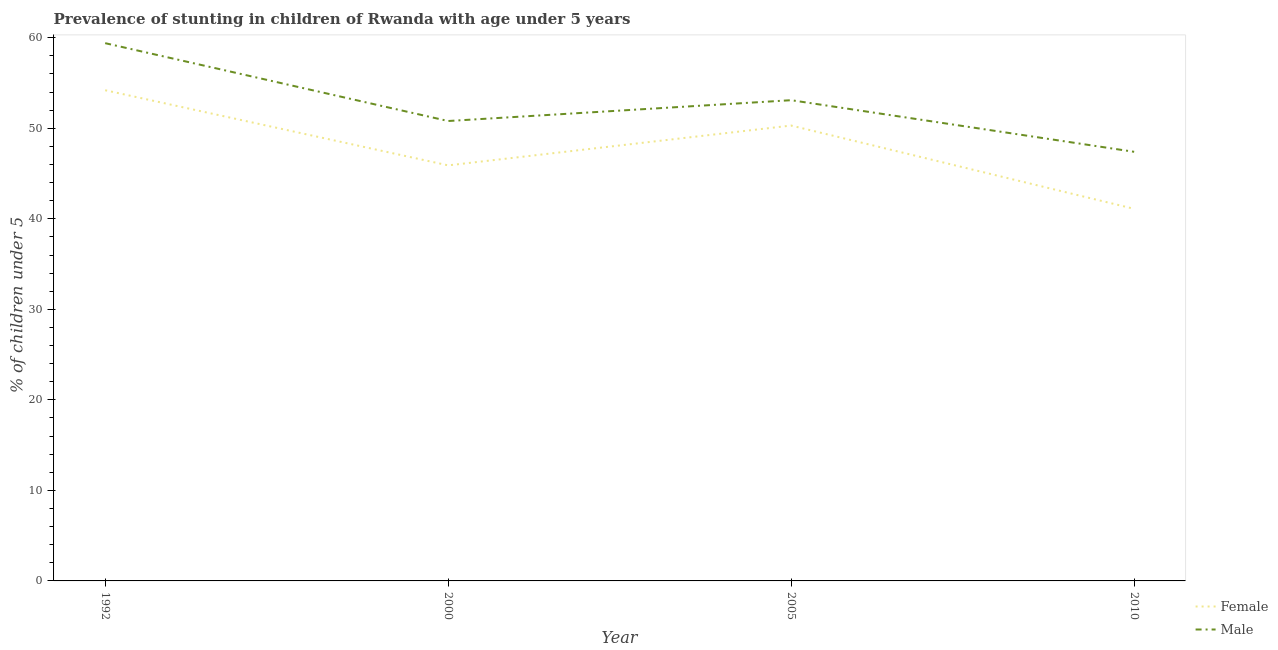How many different coloured lines are there?
Provide a succinct answer. 2. Is the number of lines equal to the number of legend labels?
Your answer should be very brief. Yes. What is the percentage of stunted male children in 1992?
Keep it short and to the point. 59.4. Across all years, what is the maximum percentage of stunted female children?
Keep it short and to the point. 54.2. Across all years, what is the minimum percentage of stunted female children?
Offer a terse response. 41.1. In which year was the percentage of stunted male children maximum?
Provide a succinct answer. 1992. What is the total percentage of stunted male children in the graph?
Your answer should be compact. 210.7. What is the difference between the percentage of stunted male children in 2000 and that in 2010?
Your answer should be very brief. 3.4. What is the average percentage of stunted male children per year?
Your answer should be very brief. 52.68. In the year 2010, what is the difference between the percentage of stunted male children and percentage of stunted female children?
Ensure brevity in your answer.  6.3. In how many years, is the percentage of stunted female children greater than 42 %?
Give a very brief answer. 3. What is the ratio of the percentage of stunted female children in 2000 to that in 2005?
Give a very brief answer. 0.91. Is the difference between the percentage of stunted female children in 2000 and 2005 greater than the difference between the percentage of stunted male children in 2000 and 2005?
Make the answer very short. No. What is the difference between the highest and the second highest percentage of stunted male children?
Offer a very short reply. 6.3. Is the sum of the percentage of stunted male children in 2005 and 2010 greater than the maximum percentage of stunted female children across all years?
Provide a short and direct response. Yes. Is the percentage of stunted male children strictly less than the percentage of stunted female children over the years?
Keep it short and to the point. No. How many lines are there?
Provide a succinct answer. 2. Does the graph contain any zero values?
Give a very brief answer. No. Does the graph contain grids?
Provide a short and direct response. No. Where does the legend appear in the graph?
Your answer should be very brief. Bottom right. What is the title of the graph?
Your answer should be compact. Prevalence of stunting in children of Rwanda with age under 5 years. Does "DAC donors" appear as one of the legend labels in the graph?
Ensure brevity in your answer.  No. What is the label or title of the Y-axis?
Make the answer very short.  % of children under 5. What is the  % of children under 5 of Female in 1992?
Make the answer very short. 54.2. What is the  % of children under 5 of Male in 1992?
Ensure brevity in your answer.  59.4. What is the  % of children under 5 of Female in 2000?
Offer a terse response. 45.9. What is the  % of children under 5 of Male in 2000?
Keep it short and to the point. 50.8. What is the  % of children under 5 in Female in 2005?
Your answer should be very brief. 50.3. What is the  % of children under 5 in Male in 2005?
Ensure brevity in your answer.  53.1. What is the  % of children under 5 of Female in 2010?
Provide a short and direct response. 41.1. What is the  % of children under 5 of Male in 2010?
Provide a succinct answer. 47.4. Across all years, what is the maximum  % of children under 5 of Female?
Keep it short and to the point. 54.2. Across all years, what is the maximum  % of children under 5 of Male?
Keep it short and to the point. 59.4. Across all years, what is the minimum  % of children under 5 of Female?
Offer a terse response. 41.1. Across all years, what is the minimum  % of children under 5 of Male?
Provide a short and direct response. 47.4. What is the total  % of children under 5 in Female in the graph?
Ensure brevity in your answer.  191.5. What is the total  % of children under 5 in Male in the graph?
Provide a succinct answer. 210.7. What is the difference between the  % of children under 5 in Female in 1992 and that in 2000?
Offer a terse response. 8.3. What is the difference between the  % of children under 5 in Male in 1992 and that in 2005?
Ensure brevity in your answer.  6.3. What is the difference between the  % of children under 5 of Female in 1992 and that in 2010?
Ensure brevity in your answer.  13.1. What is the difference between the  % of children under 5 in Female in 2000 and that in 2005?
Provide a succinct answer. -4.4. What is the difference between the  % of children under 5 of Female in 2000 and that in 2010?
Make the answer very short. 4.8. What is the difference between the  % of children under 5 of Female in 2005 and that in 2010?
Your answer should be compact. 9.2. What is the difference between the  % of children under 5 of Female in 1992 and the  % of children under 5 of Male in 2000?
Offer a terse response. 3.4. What is the difference between the  % of children under 5 of Female in 2005 and the  % of children under 5 of Male in 2010?
Keep it short and to the point. 2.9. What is the average  % of children under 5 of Female per year?
Provide a succinct answer. 47.88. What is the average  % of children under 5 of Male per year?
Your response must be concise. 52.67. In the year 2000, what is the difference between the  % of children under 5 of Female and  % of children under 5 of Male?
Provide a succinct answer. -4.9. In the year 2005, what is the difference between the  % of children under 5 in Female and  % of children under 5 in Male?
Offer a very short reply. -2.8. What is the ratio of the  % of children under 5 of Female in 1992 to that in 2000?
Your answer should be compact. 1.18. What is the ratio of the  % of children under 5 of Male in 1992 to that in 2000?
Offer a terse response. 1.17. What is the ratio of the  % of children under 5 in Female in 1992 to that in 2005?
Offer a very short reply. 1.08. What is the ratio of the  % of children under 5 in Male in 1992 to that in 2005?
Give a very brief answer. 1.12. What is the ratio of the  % of children under 5 in Female in 1992 to that in 2010?
Ensure brevity in your answer.  1.32. What is the ratio of the  % of children under 5 of Male in 1992 to that in 2010?
Your response must be concise. 1.25. What is the ratio of the  % of children under 5 of Female in 2000 to that in 2005?
Your response must be concise. 0.91. What is the ratio of the  % of children under 5 of Male in 2000 to that in 2005?
Ensure brevity in your answer.  0.96. What is the ratio of the  % of children under 5 of Female in 2000 to that in 2010?
Your response must be concise. 1.12. What is the ratio of the  % of children under 5 in Male in 2000 to that in 2010?
Keep it short and to the point. 1.07. What is the ratio of the  % of children under 5 of Female in 2005 to that in 2010?
Keep it short and to the point. 1.22. What is the ratio of the  % of children under 5 in Male in 2005 to that in 2010?
Ensure brevity in your answer.  1.12. What is the difference between the highest and the second highest  % of children under 5 of Female?
Provide a succinct answer. 3.9. 